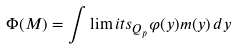<formula> <loc_0><loc_0><loc_500><loc_500>\Phi ( M ) = \int \lim i t s _ { Q _ { p } } \varphi ( y ) m ( y ) \, d y</formula> 